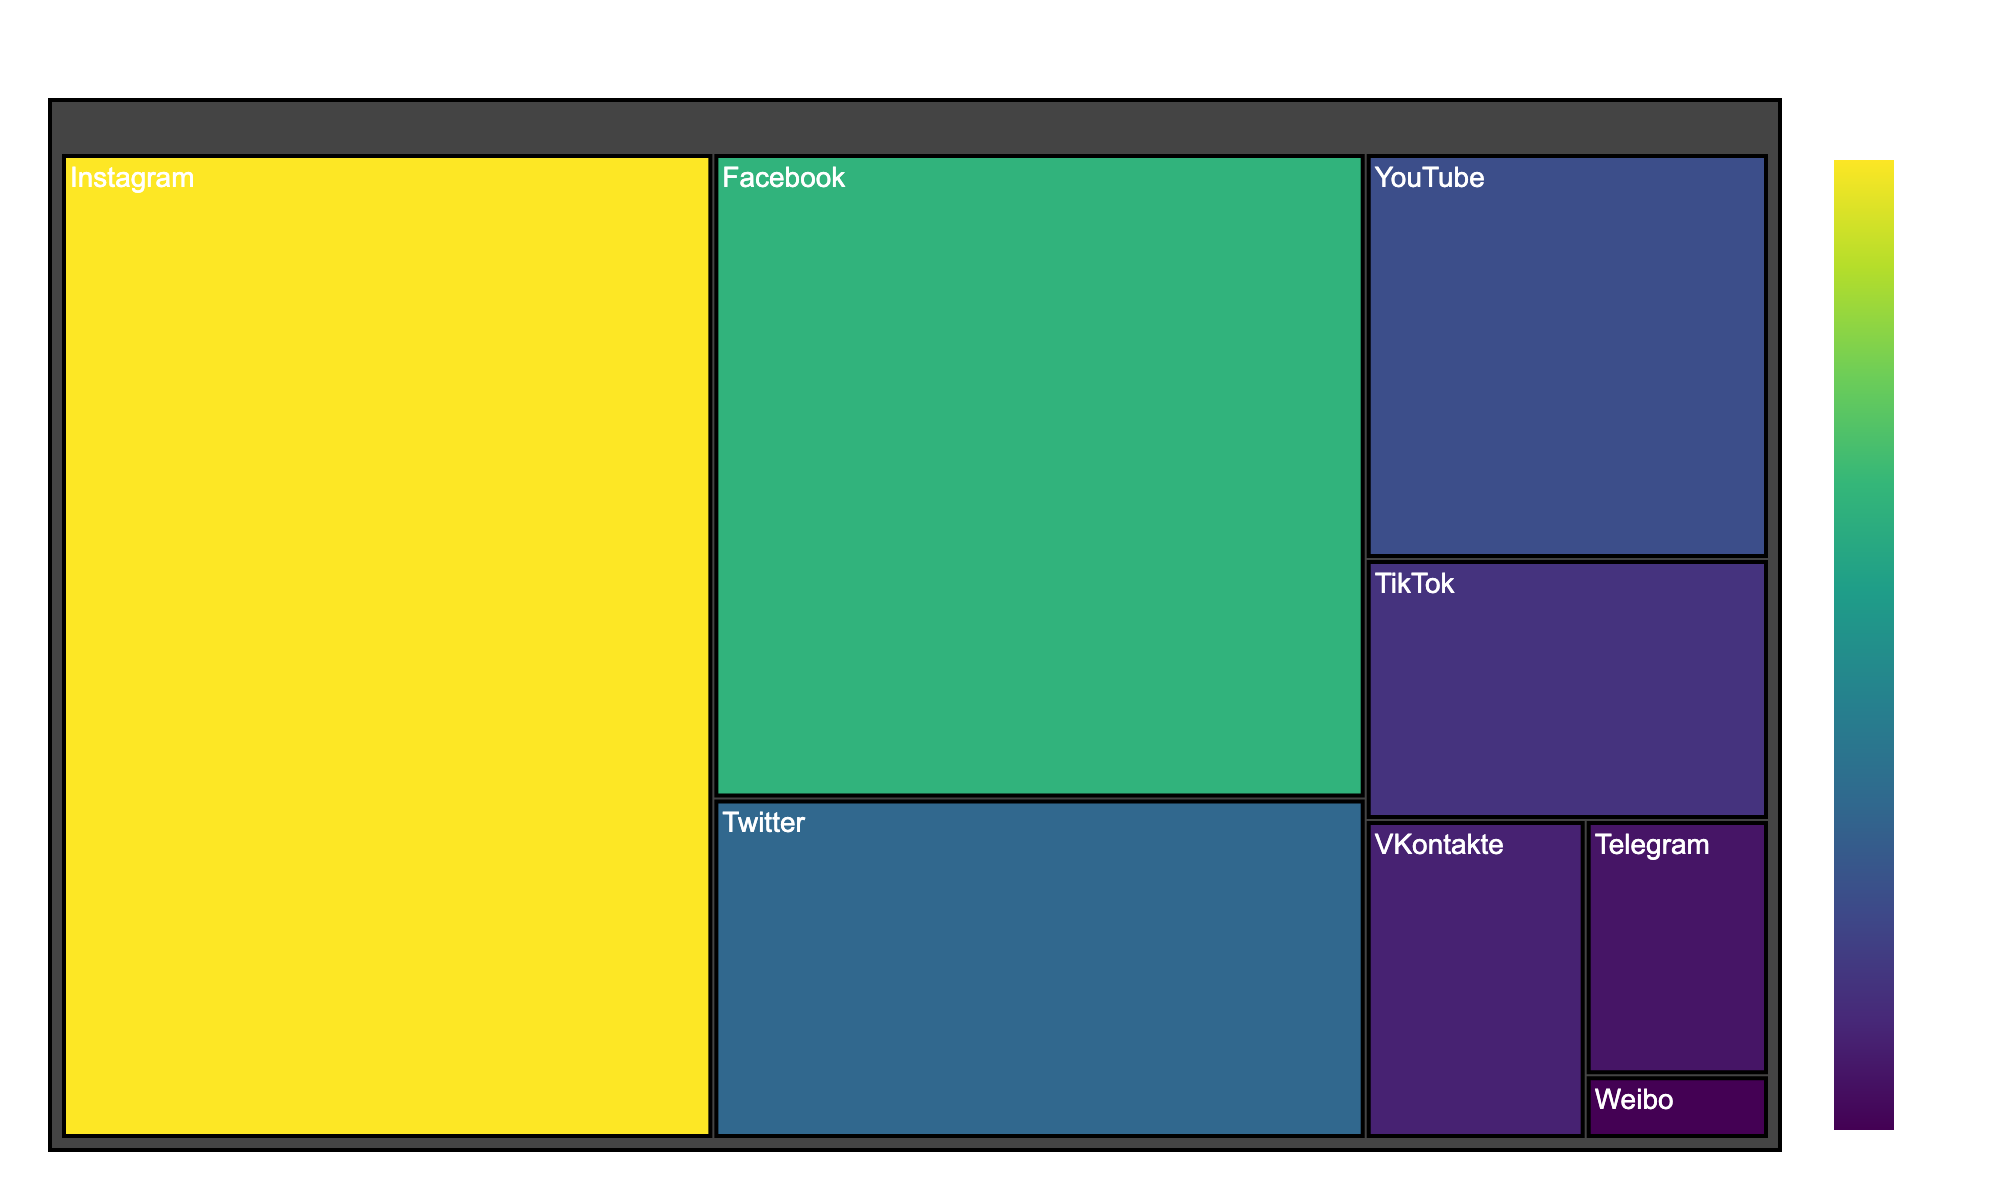what is the title of the figure? The title is usually displayed at the top of the figure. It provides an immediate understanding of what the data is about. In this case, it mentions the name and the related topic.
Answer: Vitaly Bigdash Social Media Followers Which platform has the highest number of followers? By looking at the sizes of the segments in the treemap, the largest segment represents the platform with the most followers.
Answer: Instagram What is the combined number of followers for Twitter and YouTube? First, locate the Twitter and YouTube segments. Then, sum their followers (95,000 + 70,000).
Answer: 165,000 Which platforms have fewer followers than TikTok? Compare the follower counts of VKontakte, Telegram, and Weibo to TikTok. Any segment smaller than TikTok's segment has fewer followers.
Answer: VKontakte, Telegram, Weibo What is the difference in follower count between Facebook and Instagram? Identify the follower counts for Facebook (180,000) and Instagram (275,000). Then, subtract Facebook's count from Instagram's count.
Answer: 95,000 Which platforms have more than 50,000 followers? Examine the segments and note those with follower counts greater than 50,000: Instagram, Facebook, Twitter, and YouTube.
Answer: Instagram, Facebook, Twitter, YouTube How many platforms have fewer than 100,000 followers? Count the number of segments with follower counts below 100,000: TikTok, VKontakte, Telegram, and Weibo (4 segments).
Answer: 5 platforms Which platform has the least number of followers? This would be the smallest segment in the treemap.
Answer: Weibo Is the total number of followers on Instagram greater than the combined followers on VKontakte, Telegram, and Weibo? Total combined followers for VKontakte, Telegram, and Weibo (30,000 + 20,000 + 5,000 = 55,000). Compare to Instagram's 275,000.
Answer: Yes If the followers on TikTok doubled, would it surpass the number of followers on Twitter? Calculate TikTok's doubled follower count (45,000 * 2 = 90,000) and compare it to Twitter's 95,000.
Answer: No 